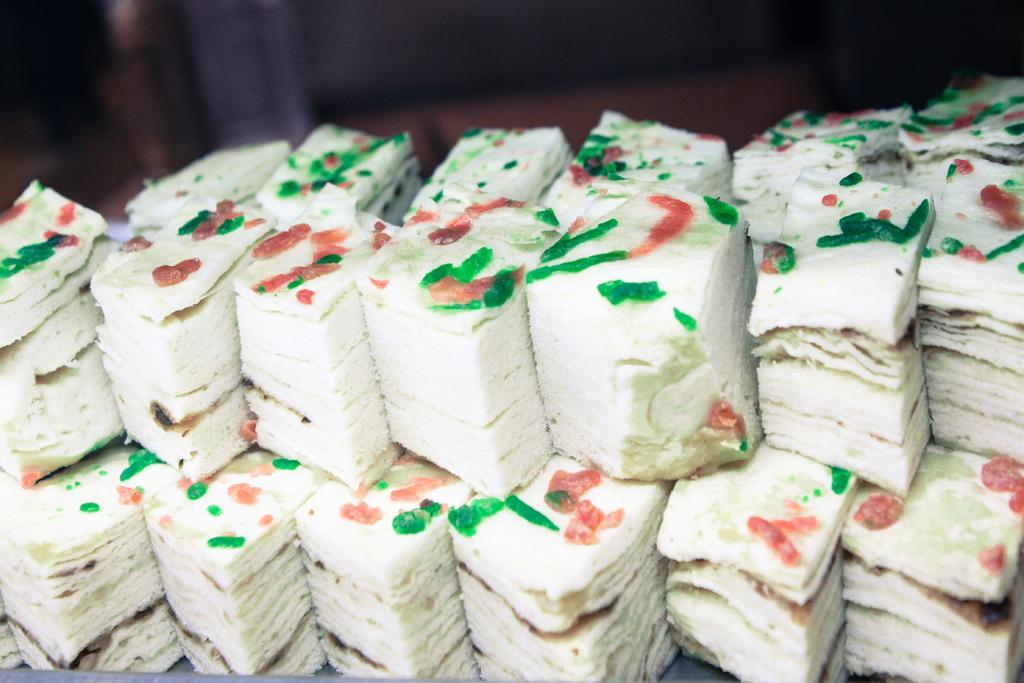How would you summarize this image in a sentence or two? In this picture, I can see a small cake pieces. 